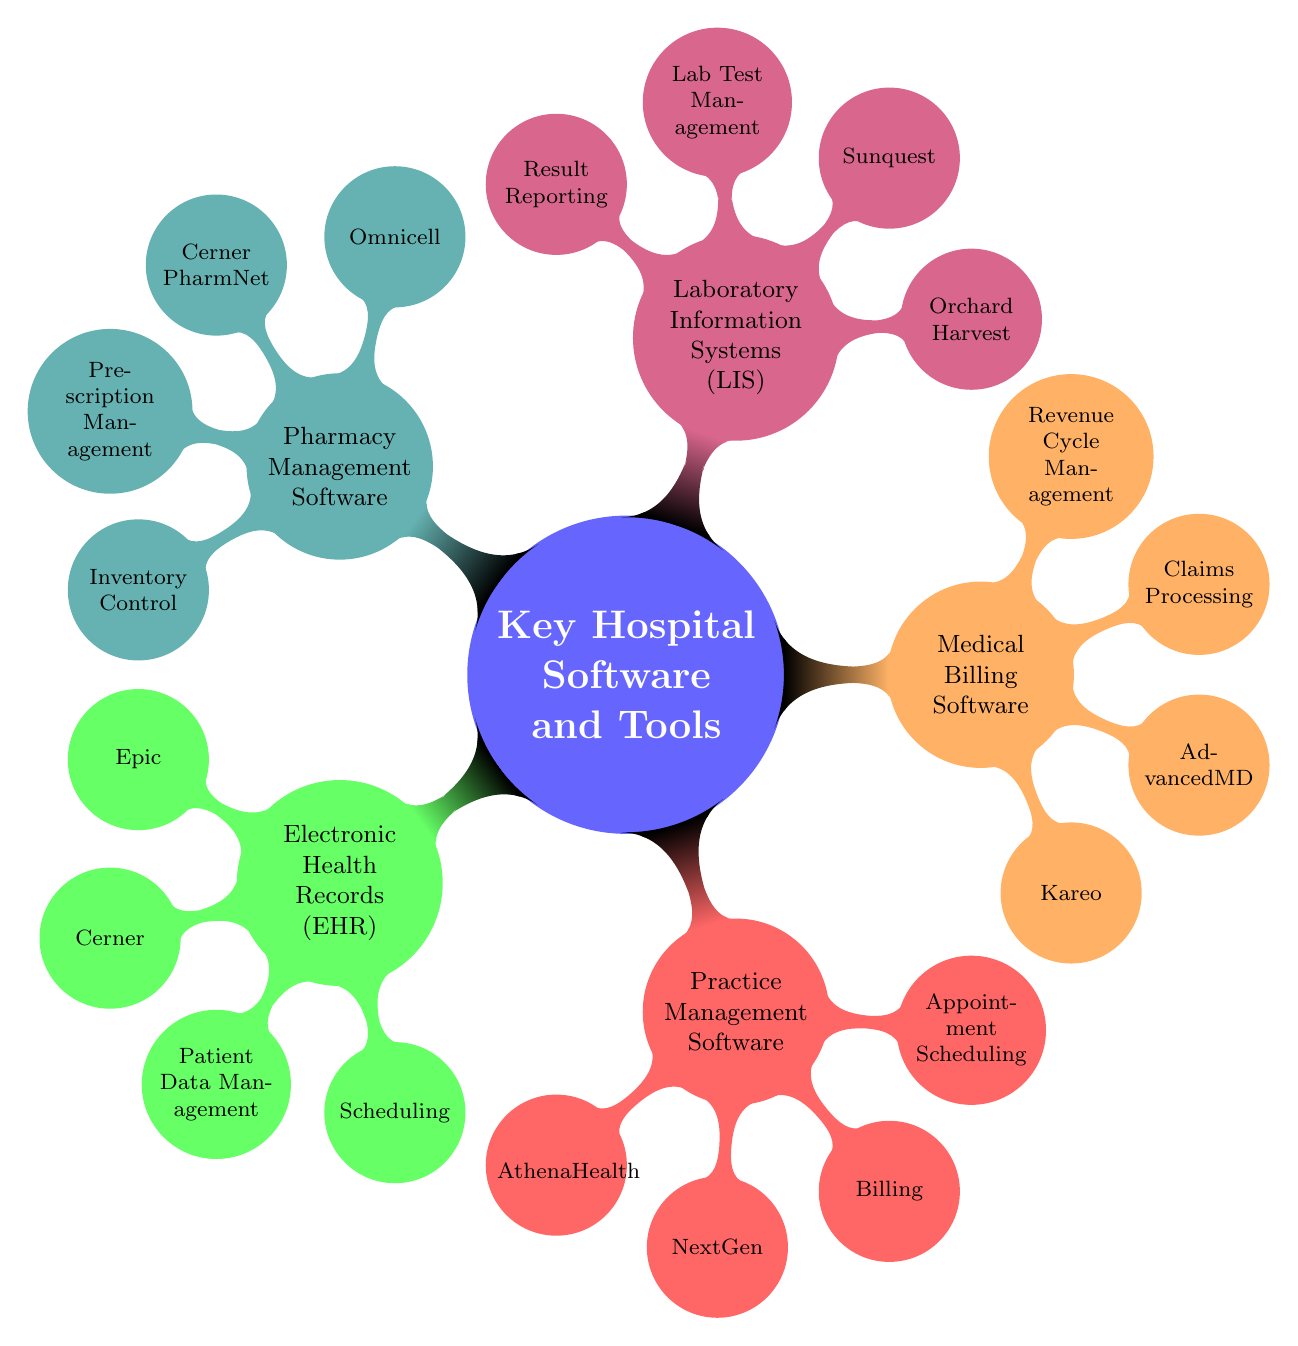What's the first node in the mind map? The first node in the mind map is the main concept labeled "Key Hospital Software and Tools." This is the central idea from which all other nodes branch out.
Answer: Key Hospital Software and Tools How many systems are listed under Electronic Health Records? There are two systems listed under Electronic Health Records, which are Epic and Cerner. I counted these items directly from the node labeled "Electronic Health Records (EHR)."
Answer: 2 What feature is common to both Practice Management Software and Medical Billing Software? Both Practice Management Software and Medical Billing Software include the feature "Billing." This is evident as it's listed under both respective nodes in the diagram.
Answer: Billing Which Pharmacy Management Software is mentioned? There are two Pharmacy Management Software systems mentioned: Omnicell and Cerner PharmNet. By referring to the "Pharmacy Management Software" node, I identified these two systems listed underneath.
Answer: Omnicell, Cerner PharmNet How many nodes describe the features of Laboratory Information Systems? There are two features described under the Laboratory Information Systems node: "Lab Test Management" and "Result Reporting." Counting these feature nodes provides the answer.
Answer: 2 Which type of software includes the feature "Appointment Scheduling"? The feature "Appointment Scheduling" is included under Practice Management Software. By tracing from the feature back to the corresponding software type, I confirmed this information.
Answer: Practice Management Software What is the color associated with Medical Billing Software? Medical Billing Software is associated with the color orange, as indicated by the concept color assigned to this node in the diagram.
Answer: Orange Which system is listed for Laboratory Information Systems? The systems listed for Laboratory Information Systems are Orchard Harvest and Sunquest. These were found directly under the "Laboratory Information Systems (LIS)" node.
Answer: Orchard Harvest, Sunquest What two roles does EHR software typically support? EHR software typically supports "Patient Data Management" and "Scheduling." Both these roles are listed as features under the EHR node in the mind map.
Answer: Patient Data Management, Scheduling 